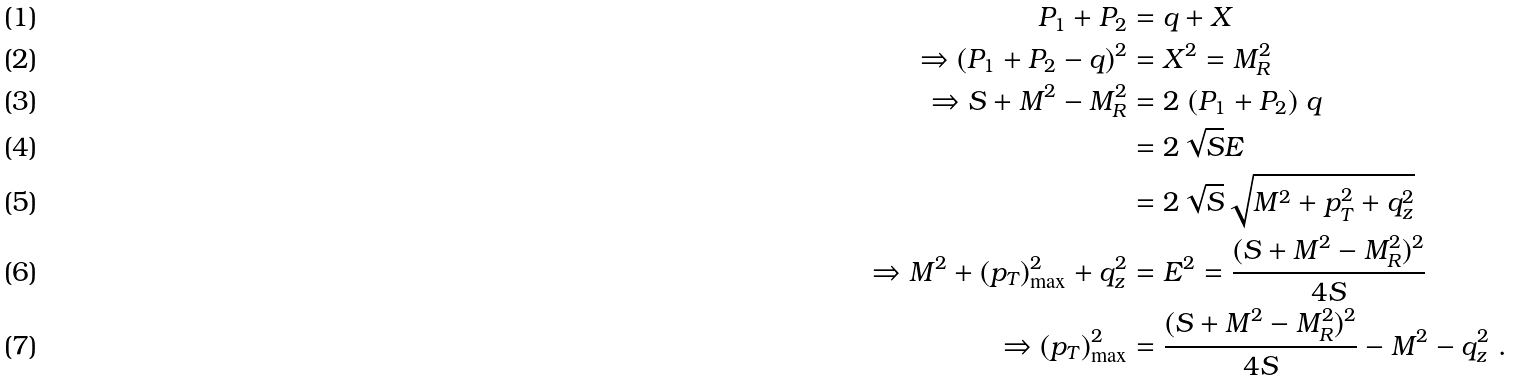<formula> <loc_0><loc_0><loc_500><loc_500>P _ { 1 } + P _ { 2 } & = q + X \\ \Rightarrow ( P _ { 1 } + P _ { 2 } - q ) ^ { 2 } & = X ^ { 2 } = M _ { R } ^ { 2 } \\ \Rightarrow S + M ^ { 2 } - M _ { R } ^ { 2 } & = 2 \ ( P _ { 1 } + P _ { 2 } ) \ q \\ & = 2 \sqrt { S } E \\ & = 2 \sqrt { S } \sqrt { M ^ { 2 } + p _ { T } ^ { 2 } + q _ { z } ^ { 2 } } \\ \Rightarrow M ^ { 2 } + ( p _ { T } ) ^ { 2 } _ { \max } + q _ { z } ^ { 2 } & = E ^ { 2 } = \frac { ( S + M ^ { 2 } - M _ { R } ^ { 2 } ) ^ { 2 } } { 4 S } \\ \Rightarrow ( p _ { T } ) ^ { 2 } _ { \max } & = \frac { ( S + M ^ { 2 } - M _ { R } ^ { 2 } ) ^ { 2 } } { 4 S } - M ^ { 2 } - q _ { z } ^ { 2 } \ .</formula> 